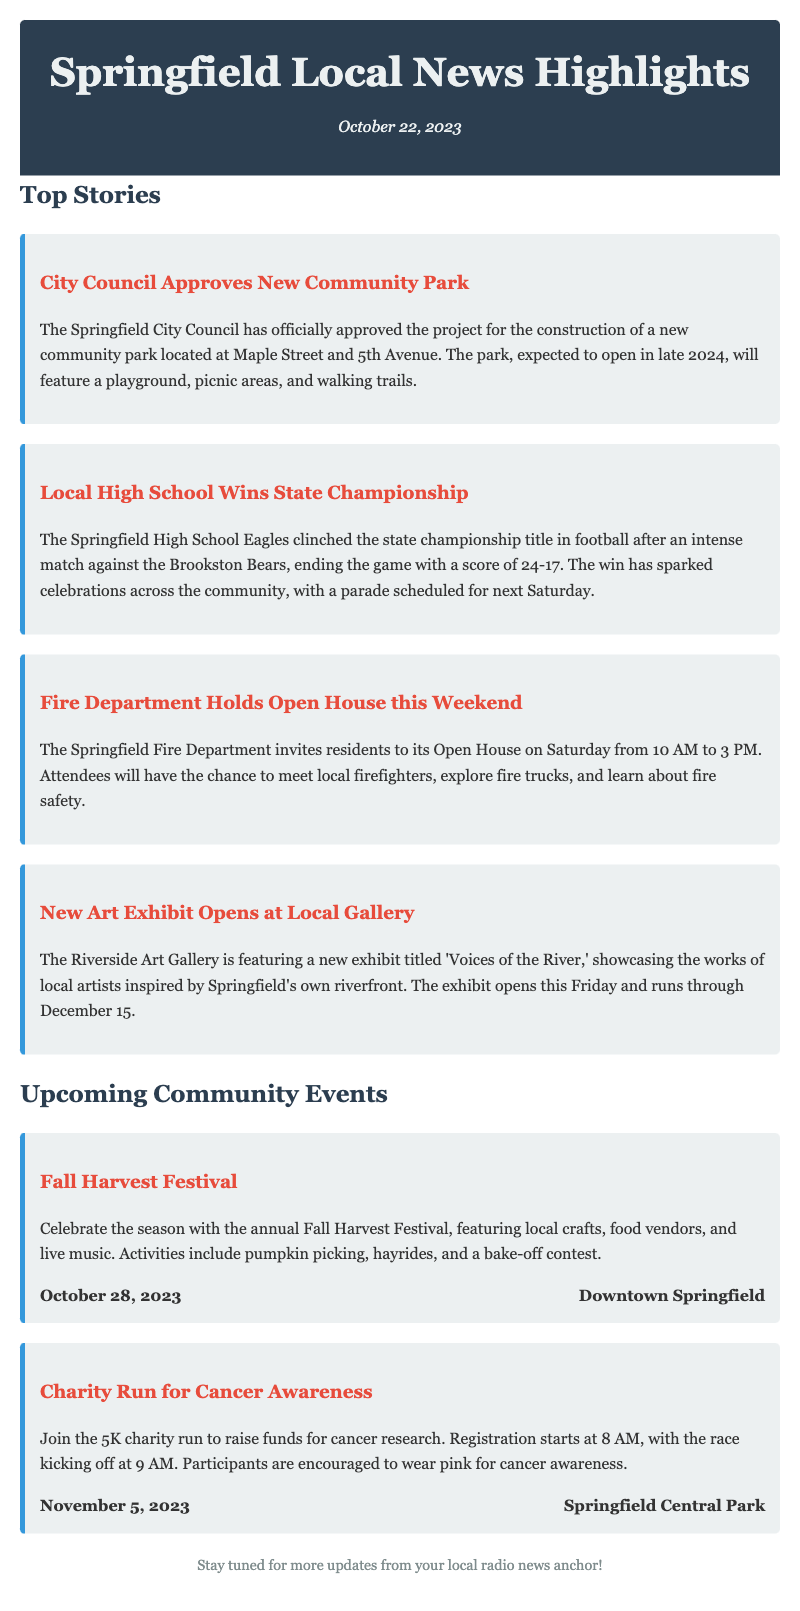What community park was approved? The document states that the Springfield City Council approved a new community park at Maple Street and 5th Avenue.
Answer: Maple Street and 5th Avenue When does the new art exhibit open? The new art exhibit titled 'Voices of the River' opens this Friday, according to the document.
Answer: This Friday What is the score of the championship game? The document mentions that the Springfield High School Eagles won the game against the Brookston Bears with a score of 24-17.
Answer: 24-17 When is the Fall Harvest Festival scheduled? The document indicates that the Fall Harvest Festival will take place on October 28, 2023.
Answer: October 28, 2023 What is the main theme of the new art exhibit? According to the document, the new exhibit showcases works inspired by Springfield's riverfront.
Answer: Voices of the River What time does the Fire Department Open House start? The document states that the Open House will be held from 10 AM to 3 PM on Saturday.
Answer: 10 AM What is the date of the charity run? The document specifies that the charity run for cancer awareness is scheduled for November 5, 2023.
Answer: November 5, 2023 What type of activities are featured at the Fall Harvest Festival? The document lists various activities like pumpkin picking, hayrides, and a bake-off contest at the Fall Harvest Festival.
Answer: Pumpkin picking, hayrides, and bake-off contest What has sparked celebrations across the community? The document mentions that the victory of the Springfield High School Eagles in the state championship has sparked celebrations.
Answer: State championship victory 